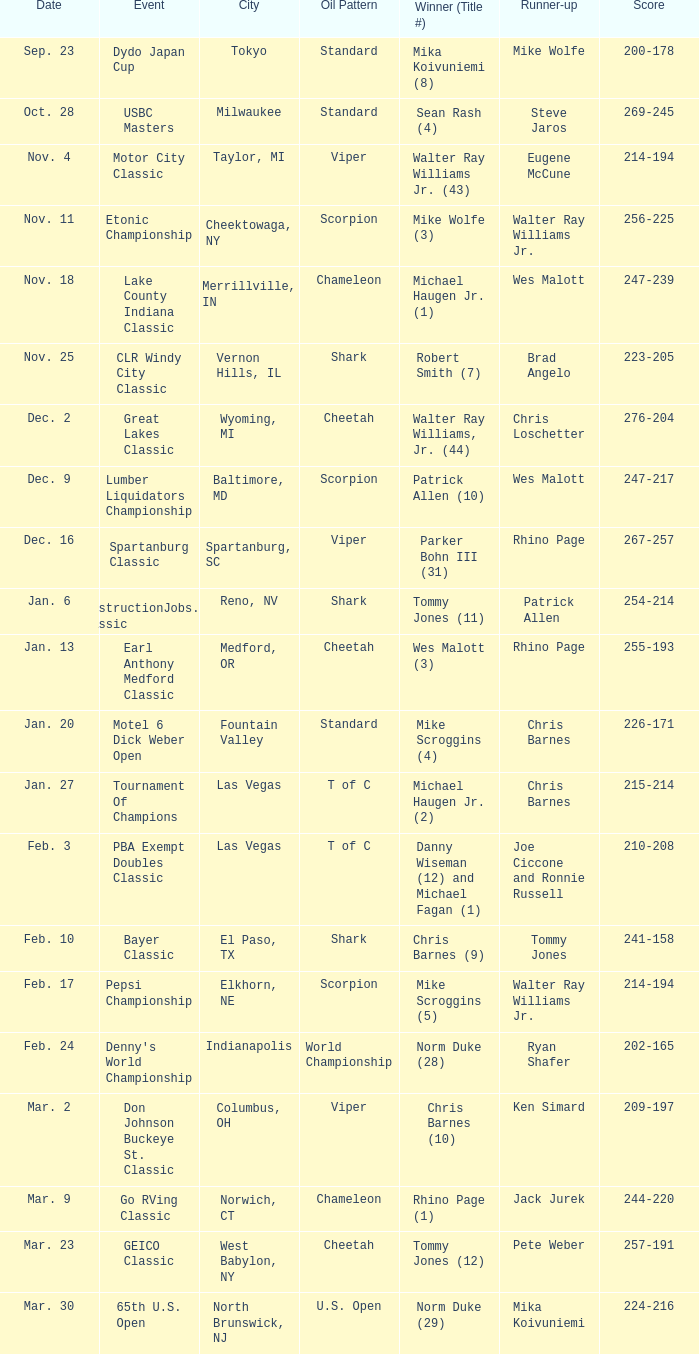What score does a constructionjobs.com classic event have? 254-214. 